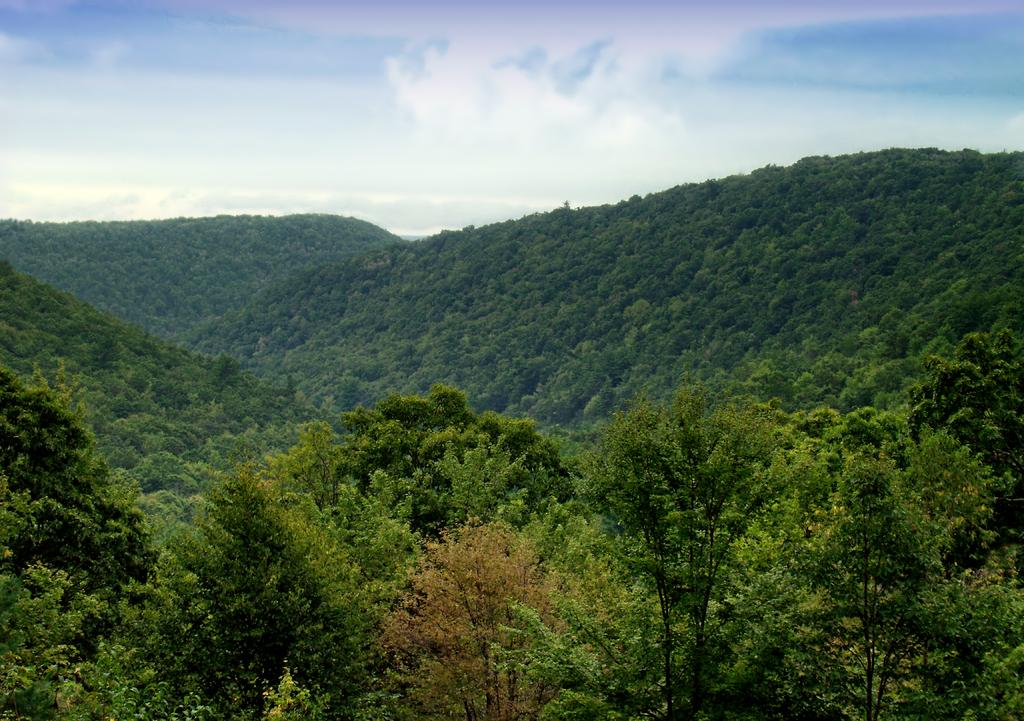What type of vegetation can be seen in the image? There are trees in the image. Are there any specific features of the trees in the image? Yes, there are mountains covered with trees in the image. What is visible in the background of the image? The sky is visible in the image. What can be seen in the sky? Clouds are present in the sky. What type of prose is being read by the trees in the image? There are no books or prose present in the image, as it features trees and mountains. What tool is being used by the wrench in the image? There is no wrench present in the image; it only contains trees, mountains, and clouds. 